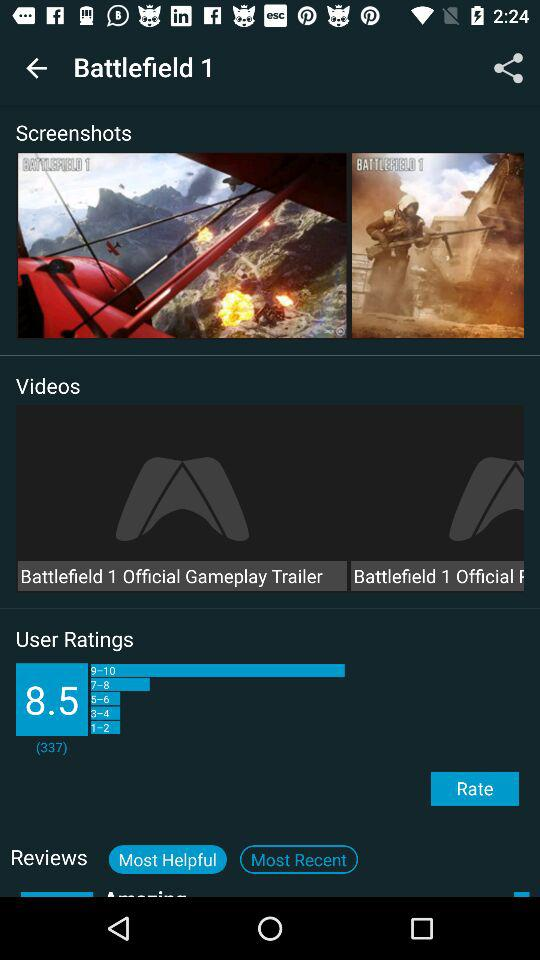How many user ratings are there?
Answer the question using a single word or phrase. 337 